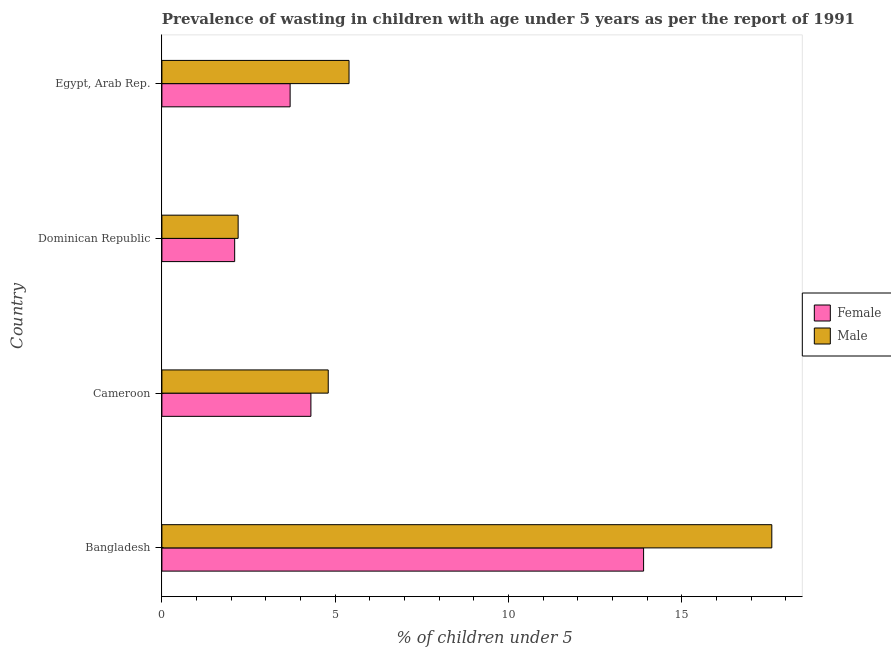How many different coloured bars are there?
Keep it short and to the point. 2. How many groups of bars are there?
Offer a terse response. 4. What is the label of the 1st group of bars from the top?
Your response must be concise. Egypt, Arab Rep. In how many cases, is the number of bars for a given country not equal to the number of legend labels?
Provide a short and direct response. 0. What is the percentage of undernourished female children in Cameroon?
Your answer should be very brief. 4.3. Across all countries, what is the maximum percentage of undernourished male children?
Provide a short and direct response. 17.6. Across all countries, what is the minimum percentage of undernourished female children?
Provide a succinct answer. 2.1. In which country was the percentage of undernourished female children maximum?
Ensure brevity in your answer.  Bangladesh. In which country was the percentage of undernourished female children minimum?
Provide a short and direct response. Dominican Republic. What is the total percentage of undernourished female children in the graph?
Make the answer very short. 24. What is the difference between the percentage of undernourished female children in Bangladesh and the percentage of undernourished male children in Dominican Republic?
Keep it short and to the point. 11.7. What is the difference between the percentage of undernourished male children and percentage of undernourished female children in Dominican Republic?
Your response must be concise. 0.1. What is the ratio of the percentage of undernourished female children in Cameroon to that in Egypt, Arab Rep.?
Your answer should be compact. 1.16. What is the difference between the highest and the lowest percentage of undernourished female children?
Offer a very short reply. 11.8. Is the sum of the percentage of undernourished male children in Bangladesh and Dominican Republic greater than the maximum percentage of undernourished female children across all countries?
Ensure brevity in your answer.  Yes. What does the 2nd bar from the top in Bangladesh represents?
Your response must be concise. Female. What does the 2nd bar from the bottom in Egypt, Arab Rep. represents?
Your answer should be compact. Male. Are all the bars in the graph horizontal?
Your answer should be compact. Yes. What is the difference between two consecutive major ticks on the X-axis?
Make the answer very short. 5. Are the values on the major ticks of X-axis written in scientific E-notation?
Keep it short and to the point. No. Where does the legend appear in the graph?
Your answer should be very brief. Center right. How are the legend labels stacked?
Provide a succinct answer. Vertical. What is the title of the graph?
Make the answer very short. Prevalence of wasting in children with age under 5 years as per the report of 1991. What is the label or title of the X-axis?
Your response must be concise.  % of children under 5. What is the label or title of the Y-axis?
Provide a succinct answer. Country. What is the  % of children under 5 of Female in Bangladesh?
Offer a very short reply. 13.9. What is the  % of children under 5 in Male in Bangladesh?
Provide a succinct answer. 17.6. What is the  % of children under 5 in Female in Cameroon?
Offer a very short reply. 4.3. What is the  % of children under 5 in Male in Cameroon?
Keep it short and to the point. 4.8. What is the  % of children under 5 of Female in Dominican Republic?
Your response must be concise. 2.1. What is the  % of children under 5 in Male in Dominican Republic?
Offer a terse response. 2.2. What is the  % of children under 5 of Female in Egypt, Arab Rep.?
Your response must be concise. 3.7. What is the  % of children under 5 of Male in Egypt, Arab Rep.?
Offer a terse response. 5.4. Across all countries, what is the maximum  % of children under 5 of Female?
Your response must be concise. 13.9. Across all countries, what is the maximum  % of children under 5 of Male?
Provide a succinct answer. 17.6. Across all countries, what is the minimum  % of children under 5 in Female?
Your answer should be compact. 2.1. Across all countries, what is the minimum  % of children under 5 in Male?
Offer a very short reply. 2.2. What is the total  % of children under 5 in Female in the graph?
Ensure brevity in your answer.  24. What is the difference between the  % of children under 5 in Male in Bangladesh and that in Cameroon?
Your answer should be compact. 12.8. What is the difference between the  % of children under 5 of Female in Bangladesh and that in Dominican Republic?
Your response must be concise. 11.8. What is the difference between the  % of children under 5 of Female in Bangladesh and that in Egypt, Arab Rep.?
Provide a short and direct response. 10.2. What is the difference between the  % of children under 5 of Male in Bangladesh and that in Egypt, Arab Rep.?
Your answer should be compact. 12.2. What is the difference between the  % of children under 5 in Female in Cameroon and that in Egypt, Arab Rep.?
Your answer should be very brief. 0.6. What is the difference between the  % of children under 5 of Male in Cameroon and that in Egypt, Arab Rep.?
Offer a very short reply. -0.6. What is the difference between the  % of children under 5 in Male in Dominican Republic and that in Egypt, Arab Rep.?
Provide a succinct answer. -3.2. What is the difference between the  % of children under 5 in Female in Bangladesh and the  % of children under 5 in Male in Egypt, Arab Rep.?
Your answer should be compact. 8.5. What is the difference between the  % of children under 5 of Female in Cameroon and the  % of children under 5 of Male in Dominican Republic?
Provide a succinct answer. 2.1. What is the difference between the  % of children under 5 in Female in Dominican Republic and the  % of children under 5 in Male in Egypt, Arab Rep.?
Your answer should be very brief. -3.3. What is the average  % of children under 5 of Female per country?
Your response must be concise. 6. What is the difference between the  % of children under 5 in Female and  % of children under 5 in Male in Bangladesh?
Ensure brevity in your answer.  -3.7. What is the ratio of the  % of children under 5 of Female in Bangladesh to that in Cameroon?
Give a very brief answer. 3.23. What is the ratio of the  % of children under 5 of Male in Bangladesh to that in Cameroon?
Ensure brevity in your answer.  3.67. What is the ratio of the  % of children under 5 in Female in Bangladesh to that in Dominican Republic?
Offer a terse response. 6.62. What is the ratio of the  % of children under 5 in Female in Bangladesh to that in Egypt, Arab Rep.?
Provide a short and direct response. 3.76. What is the ratio of the  % of children under 5 of Male in Bangladesh to that in Egypt, Arab Rep.?
Provide a succinct answer. 3.26. What is the ratio of the  % of children under 5 of Female in Cameroon to that in Dominican Republic?
Provide a short and direct response. 2.05. What is the ratio of the  % of children under 5 in Male in Cameroon to that in Dominican Republic?
Offer a very short reply. 2.18. What is the ratio of the  % of children under 5 of Female in Cameroon to that in Egypt, Arab Rep.?
Provide a succinct answer. 1.16. What is the ratio of the  % of children under 5 of Female in Dominican Republic to that in Egypt, Arab Rep.?
Your answer should be compact. 0.57. What is the ratio of the  % of children under 5 of Male in Dominican Republic to that in Egypt, Arab Rep.?
Provide a short and direct response. 0.41. What is the difference between the highest and the second highest  % of children under 5 of Female?
Provide a short and direct response. 9.6. What is the difference between the highest and the lowest  % of children under 5 in Female?
Provide a succinct answer. 11.8. 